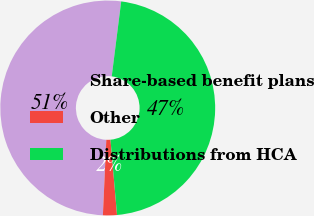Convert chart to OTSL. <chart><loc_0><loc_0><loc_500><loc_500><pie_chart><fcel>Share-based benefit plans<fcel>Other<fcel>Distributions from HCA<nl><fcel>51.28%<fcel>2.1%<fcel>46.62%<nl></chart> 